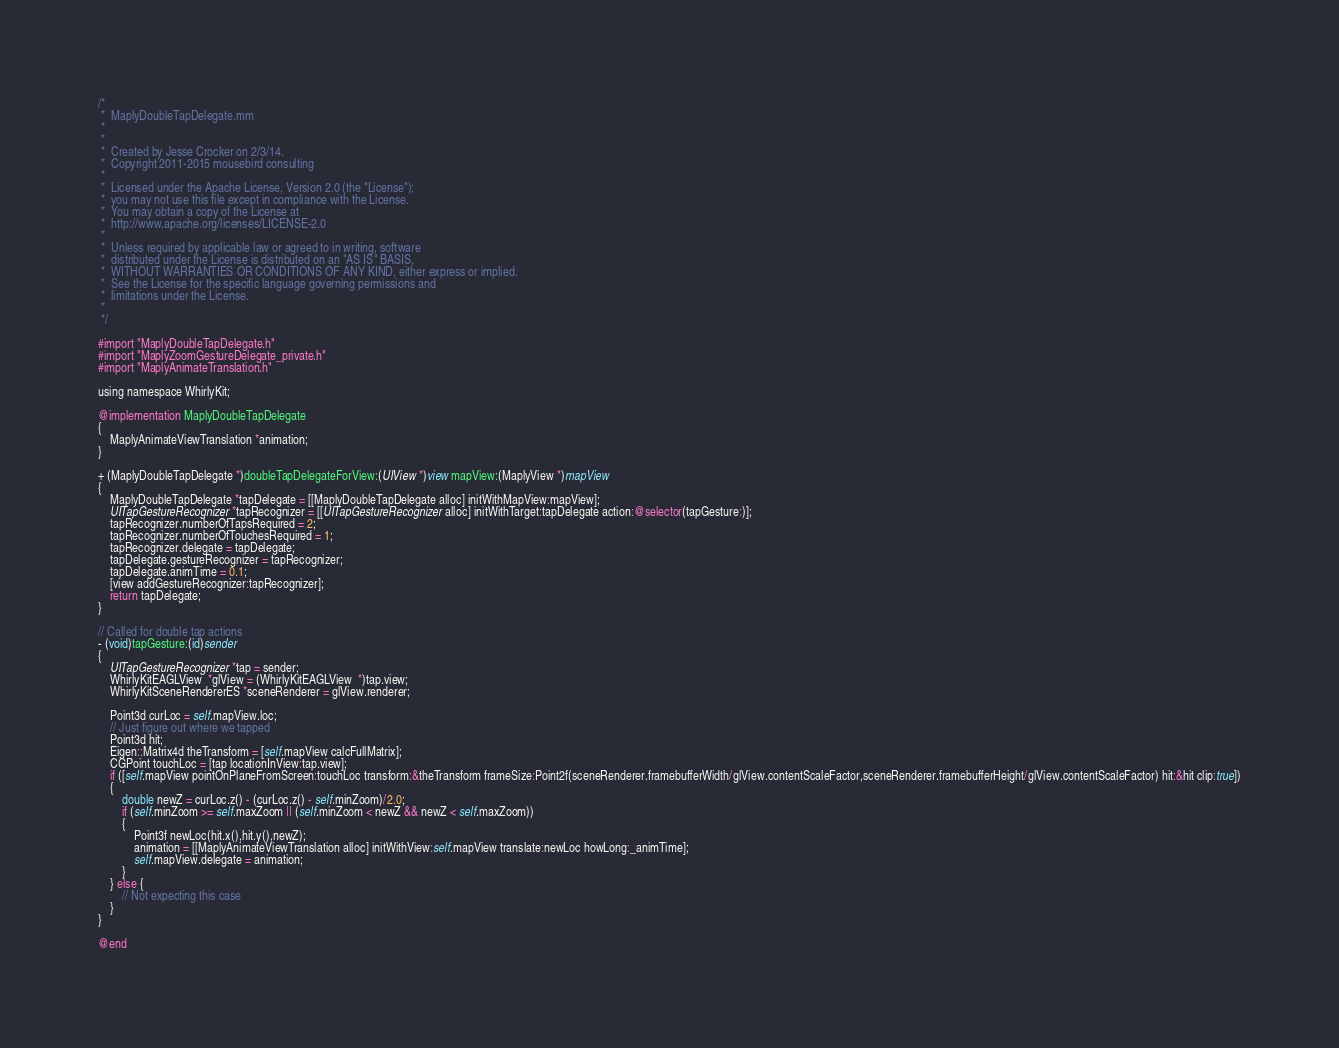Convert code to text. <code><loc_0><loc_0><loc_500><loc_500><_ObjectiveC_>/*
 *  MaplyDoubleTapDelegate.mm
 *
 *
 *  Created by Jesse Crocker on 2/3/14.
 *  Copyright 2011-2015 mousebird consulting
 *
 *  Licensed under the Apache License, Version 2.0 (the "License");
 *  you may not use this file except in compliance with the License.
 *  You may obtain a copy of the License at
 *  http://www.apache.org/licenses/LICENSE-2.0
 *
 *  Unless required by applicable law or agreed to in writing, software
 *  distributed under the License is distributed on an "AS IS" BASIS,
 *  WITHOUT WARRANTIES OR CONDITIONS OF ANY KIND, either express or implied.
 *  See the License for the specific language governing permissions and
 *  limitations under the License.
 *
 */

#import "MaplyDoubleTapDelegate.h"
#import "MaplyZoomGestureDelegate_private.h"
#import "MaplyAnimateTranslation.h"

using namespace WhirlyKit;

@implementation MaplyDoubleTapDelegate
{
    MaplyAnimateViewTranslation *animation;
}

+ (MaplyDoubleTapDelegate *)doubleTapDelegateForView:(UIView *)view mapView:(MaplyView *)mapView
{
    MaplyDoubleTapDelegate *tapDelegate = [[MaplyDoubleTapDelegate alloc] initWithMapView:mapView];
    UITapGestureRecognizer *tapRecognizer = [[UITapGestureRecognizer alloc] initWithTarget:tapDelegate action:@selector(tapGesture:)];
    tapRecognizer.numberOfTapsRequired = 2;
    tapRecognizer.numberOfTouchesRequired = 1;
    tapRecognizer.delegate = tapDelegate;
    tapDelegate.gestureRecognizer = tapRecognizer;
    tapDelegate.animTime = 0.1;
	[view addGestureRecognizer:tapRecognizer];
	return tapDelegate;
}

// Called for double tap actions
- (void)tapGesture:(id)sender
{
    UITapGestureRecognizer *tap = sender;
    WhirlyKitEAGLView  *glView = (WhirlyKitEAGLView  *)tap.view;
    WhirlyKitSceneRendererES *sceneRenderer = glView.renderer;
	
    Point3d curLoc = self.mapView.loc;
    // Just figure out where we tapped
	Point3d hit;
    Eigen::Matrix4d theTransform = [self.mapView calcFullMatrix];
    CGPoint touchLoc = [tap locationInView:tap.view];
    if ([self.mapView pointOnPlaneFromScreen:touchLoc transform:&theTransform frameSize:Point2f(sceneRenderer.framebufferWidth/glView.contentScaleFactor,sceneRenderer.framebufferHeight/glView.contentScaleFactor) hit:&hit clip:true])
    {
        double newZ = curLoc.z() - (curLoc.z() - self.minZoom)/2.0;
        if (self.minZoom >= self.maxZoom || (self.minZoom < newZ && newZ < self.maxZoom))
        {
            Point3f newLoc(hit.x(),hit.y(),newZ);
            animation = [[MaplyAnimateViewTranslation alloc] initWithView:self.mapView translate:newLoc howLong:_animTime];
            self.mapView.delegate = animation;
        }
    } else {
        // Not expecting this case
    }
}

@end
</code> 